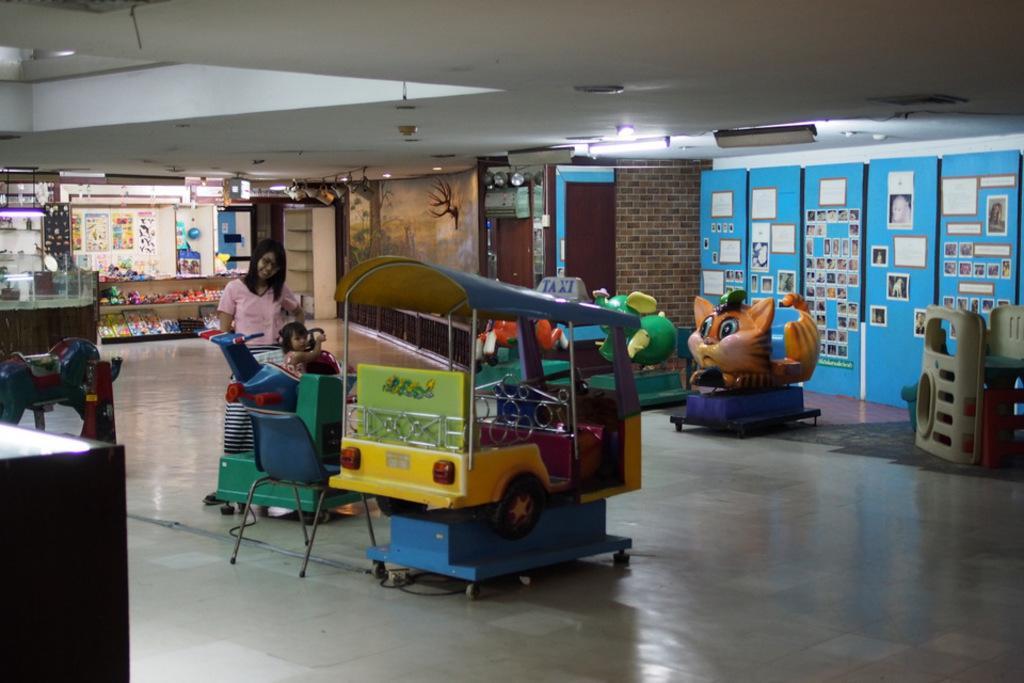Please provide a concise description of this image. In this image I can see number of children's rides and on the one ride I can see a girl is sitting. I can also see a woman is standing in the centre of the image and on the both sides of the image I can see number of posters on the walls. On the top side of this image I can see number of lights on the ceiling. 